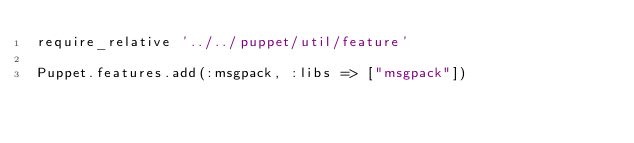<code> <loc_0><loc_0><loc_500><loc_500><_Ruby_>require_relative '../../puppet/util/feature'

Puppet.features.add(:msgpack, :libs => ["msgpack"])
</code> 